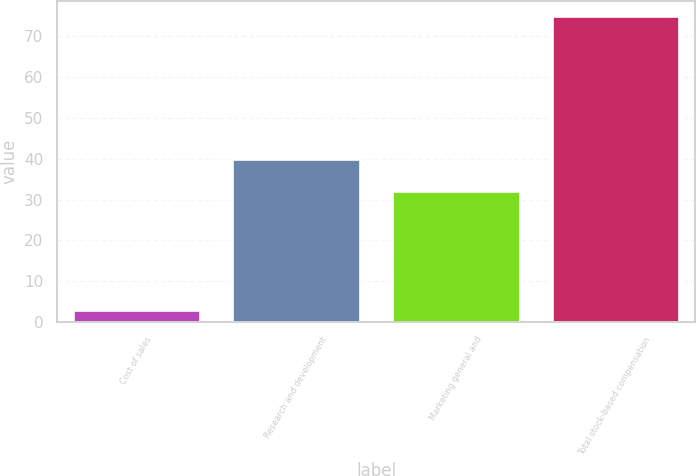Convert chart to OTSL. <chart><loc_0><loc_0><loc_500><loc_500><bar_chart><fcel>Cost of sales<fcel>Research and development<fcel>Marketing general and<fcel>Total stock-based compensation<nl><fcel>3<fcel>40<fcel>32<fcel>75<nl></chart> 